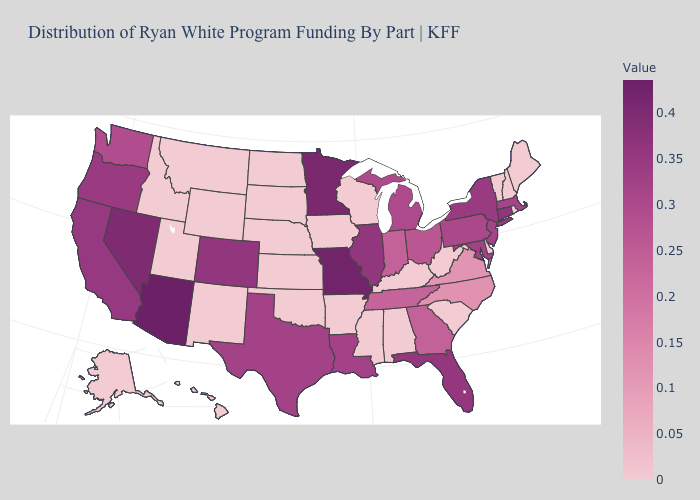Among the states that border Florida , does Georgia have the lowest value?
Answer briefly. No. Does Maryland have the lowest value in the USA?
Short answer required. No. Which states have the highest value in the USA?
Answer briefly. Arizona. Does Missouri have the highest value in the MidWest?
Short answer required. Yes. Does Connecticut have the highest value in the Northeast?
Be succinct. Yes. 